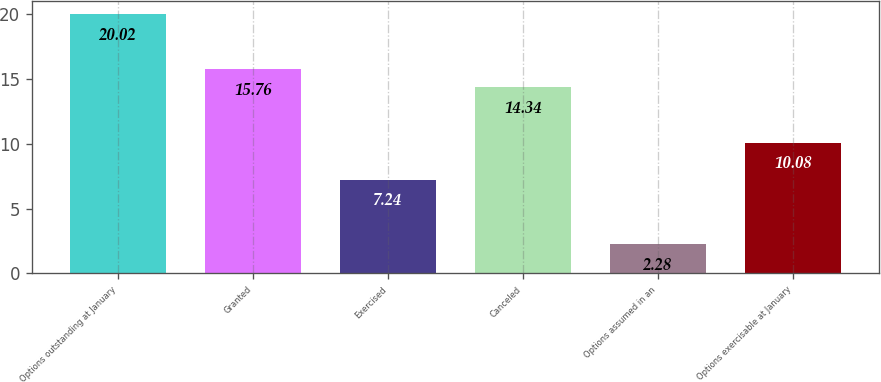<chart> <loc_0><loc_0><loc_500><loc_500><bar_chart><fcel>Options outstanding at January<fcel>Granted<fcel>Exercised<fcel>Canceled<fcel>Options assumed in an<fcel>Options exercisable at January<nl><fcel>20.02<fcel>15.76<fcel>7.24<fcel>14.34<fcel>2.28<fcel>10.08<nl></chart> 